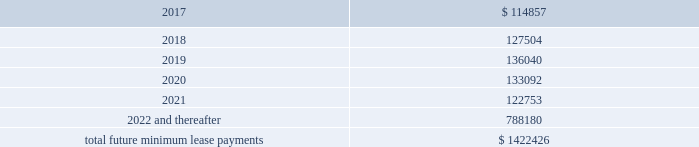Interest expense , net was $ 26.4 million , $ 14.6 million , and $ 5.3 million for the years ended december 31 , 2016 , 2015 and 2014 , respectively .
Interest expense includes the amortization of deferred financing costs , bank fees , capital and built-to-suit lease interest and interest expense under the credit and other long term debt facilities .
Amortization of deferred financing costs was $ 1.2 million , $ 0.8 million , and $ 0.6 million for the years ended december 31 , 2016 , 2015 and 2014 , respectively .
The company monitors the financial health and stability of its lenders under the credit and other long term debt facilities , however during any period of significant instability in the credit markets lenders could be negatively impacted in their ability to perform under these facilities .
Commitments and contingencies obligations under operating leases the company leases warehouse space , office facilities , space for its brand and factory house stores and certain equipment under non-cancelable operating leases .
The leases expire at various dates through 2033 , excluding extensions at the company 2019s option , and include provisions for rental adjustments .
The table below includes executed lease agreements for brand and factory house stores that the company did not yet occupy as of december 31 , 2016 and does not include contingent rent the company may incur at its stores based on future sales above a specified minimum or payments made for maintenance , insurance and real estate taxes .
The following is a schedule of future minimum lease payments for non-cancelable real property operating leases as of december 31 , 2016 as well as significant operating lease agreements entered into during the period after december 31 , 2016 through the date of this report : ( in thousands ) .
Included in selling , general and administrative expense was rent expense of $ 109.0 million , $ 83.0 million and $ 59.0 million for the years ended december 31 , 2016 , 2015 and 2014 , respectively , under non-cancelable operating lease agreements .
Included in these amounts was contingent rent expense of $ 13.0 million , $ 11.0 million and $ 11.0 million for the years ended december 31 , 2016 , 2015 and 2014 , respectively .
Sports marketing and other commitments within the normal course of business , the company enters into contractual commitments in order to promote the company 2019s brand and products .
These commitments include sponsorship agreements with teams and athletes on the collegiate and professional levels , official supplier agreements , athletic event sponsorships and other marketing commitments .
The following is a schedule of the company 2019s future minimum payments under its sponsorship and other marketing agreements as of december 31 .
What was the percentage change in rent expenses included in selling , general and administrative expense from 2015 to 2016? 
Computations: ((109.0 - 83.0) / 83.0)
Answer: 0.31325. 